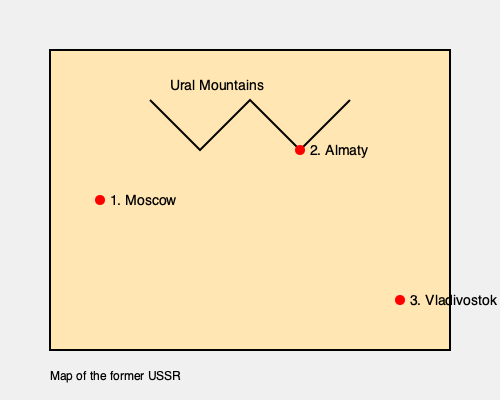In the map of the former USSR above, which numbered location corresponds to the filming site of Andrei Tarkovsky's "Stalker" (1979), known for its industrial landscapes and abandoned buildings? To answer this question, we need to consider the following steps:

1. Recall that "Stalker" (1979) is a Soviet science fiction film directed by Andrei Tarkovsky.

2. The film is known for its depiction of a post-apocalyptic industrial landscape, often referred to as "The Zone."

3. While the film's setting is fictional, the actual filming locations were primarily in Estonia, which was part of the Soviet Union at the time.

4. Estonia is located in the western part of the former USSR, close to the Baltic Sea.

5. Looking at the map provided:
   - Location 1 is labeled as Moscow, which is in the western part of Russia.
   - Location 2 is labeled as Almaty, which is in Kazakhstan, in Central Asia.
   - Location 3 is labeled as Vladivostok, which is in the far eastern part of Russia.

6. Among these options, Moscow (Location 1) is the closest to Estonia and the Baltic region.

7. While "Stalker" wasn't filmed in Moscow itself, the Moscow location on this simplified map best represents the general region where the film was shot.

Therefore, Location 1 (Moscow) is the best answer among the given options, as it most closely represents the geographic region where "Stalker" was filmed.
Answer: 1. Moscow 